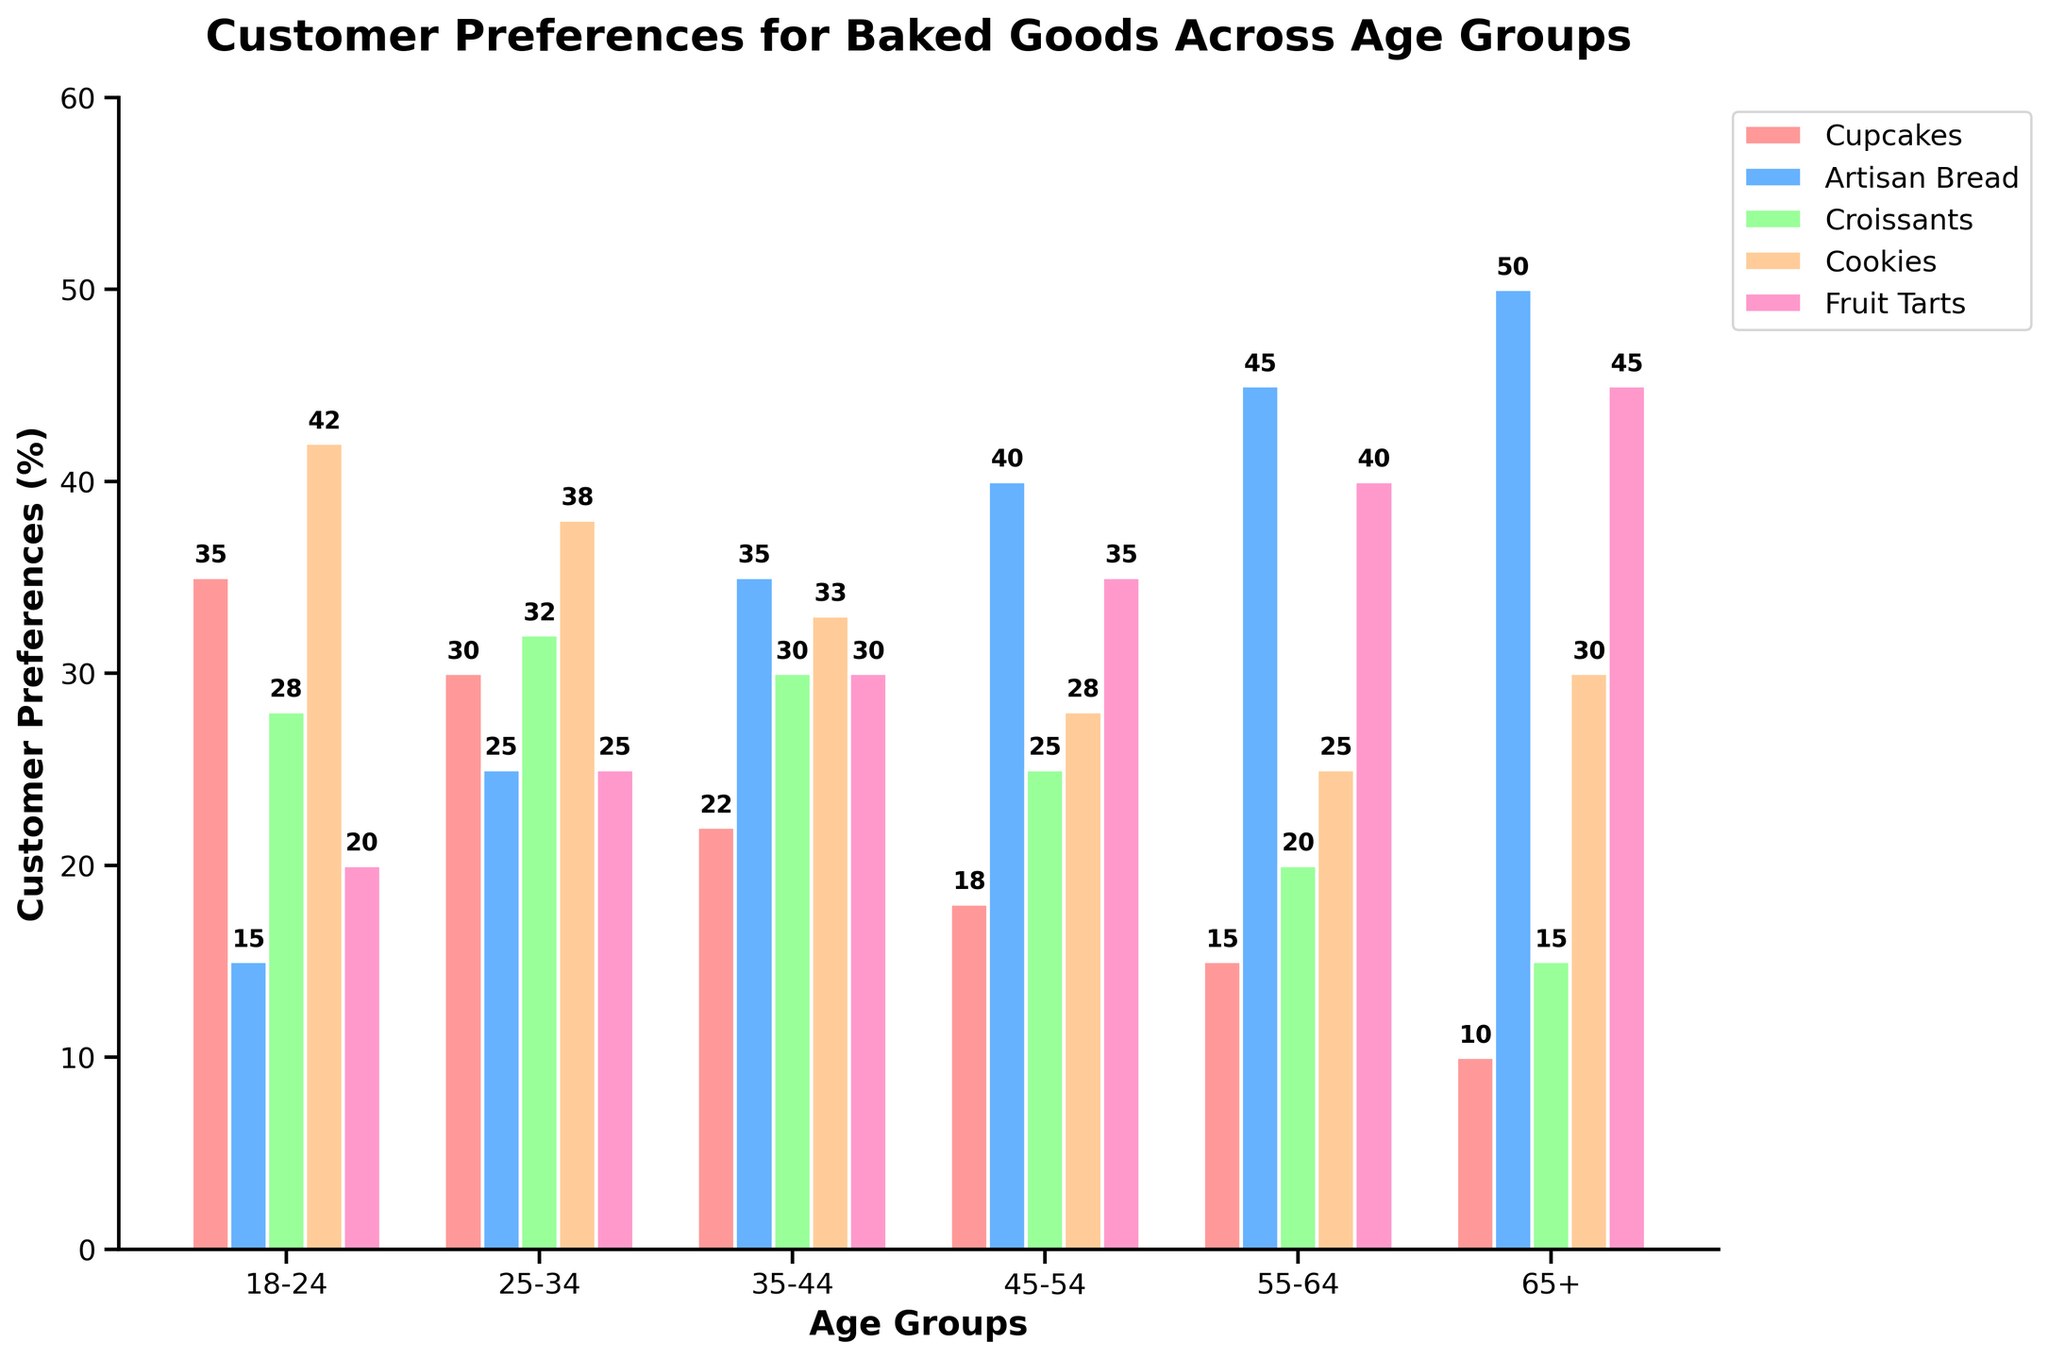Which age group has the highest preference for Artisan Bread? The bar for Artisan Bread in the "65+" age group is the tallest, indicating the highest preference.
Answer: 65+ Which baked good is the least preferred by the 18-24 age group? The bar for Artisan Bread in the "18-24" age group is the shortest among all bars for that age group.
Answer: Artisan Bread What is the combined preference percentage for Croissants and Cookies in the 35-44 age group? Add the preference percentages for Croissants (30) and Cookies (33) in the 35-44 age group: 30 + 33.
Answer: 63 Between the 25-34 and 45-54 age groups, which has a higher preference for Cupcakes? Compare the heights of the bars for Cupcakes in the 25-34 and 45-54 age groups. The bar for 25-34 is taller.
Answer: 25-34 Which age group shows an equal preference for Cookies and another baked good? The 65+ age group shows equal preference for Cookies and Cupcakes, both represented by bars of the same height (30).
Answer: 65+ What is the average preference percentage for Fruit Tarts across all age groups? Sum the preference percentages for Fruit Tarts across all age groups and divide by the number of groups: (20 + 25 + 30 + 35 + 40 + 45) / 6 = 195 / 6.
Answer: 32.5 How does the preference for Artisan Bread change as age increases? Observe the bars for Artisan Bread across age groups; it increases from left to right. The preference rises consistently as age increases.
Answer: Increases Is it true that the preference for Croissants is always lower than that for Cookies across all age groups? Compare the heights of the Croissants and Cookies bars across all age groups. They are always lower, so the statement is true.
Answer: True What is the difference in preference for Fruit Tarts between the 55-64 and 18-24 age groups? Subtract the preference percentage for the 18-24 age group from that of the 55-64 age group: 40 - 20.
Answer: 20 